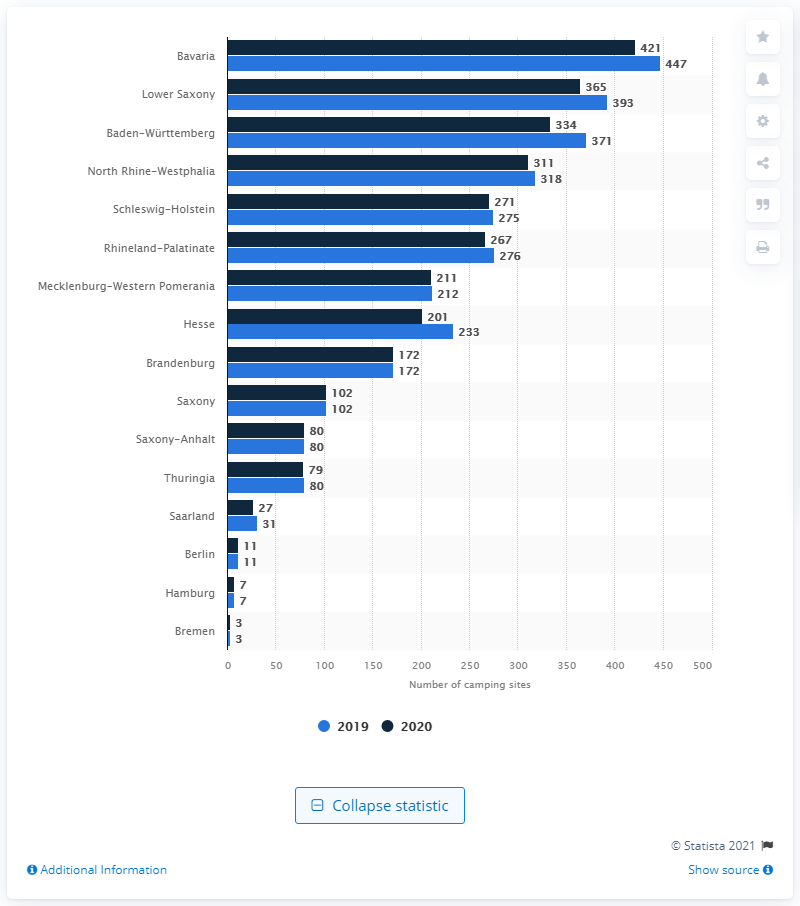Which state showed the greatest increase in camping sites from 2019 to 2020? Upon examining the data, the state showing the most significant rise in the number of camping sites from 2019 to 2020 is Lower Saxony, with an increase indicating a substantial investment in camping and outdoor recreational facilities. 